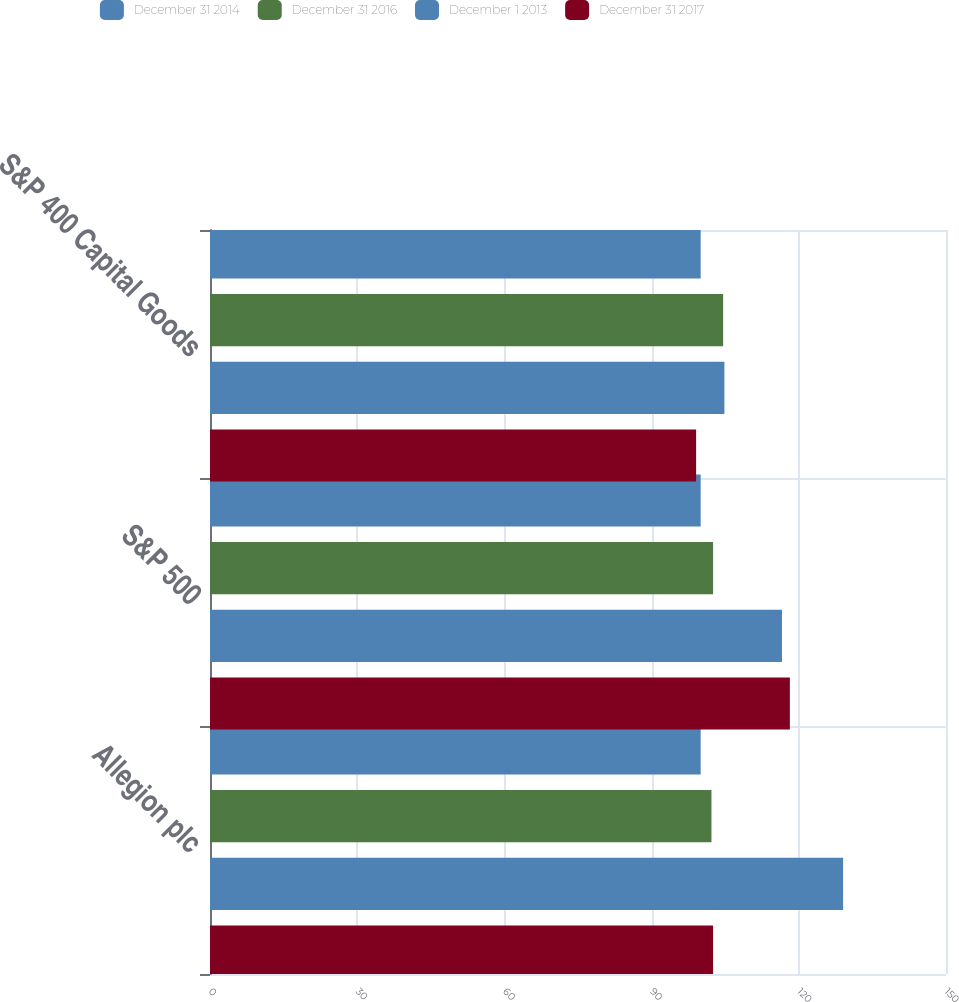Convert chart to OTSL. <chart><loc_0><loc_0><loc_500><loc_500><stacked_bar_chart><ecel><fcel>Allegion plc<fcel>S&P 500<fcel>S&P 400 Capital Goods<nl><fcel>December 31 2014<fcel>100<fcel>100<fcel>100<nl><fcel>December 31 2016<fcel>102.2<fcel>102.53<fcel>104.58<nl><fcel>December 1 2013<fcel>129.03<fcel>116.57<fcel>104.84<nl><fcel>December 31 2017<fcel>102.53<fcel>118.18<fcel>99.07<nl></chart> 